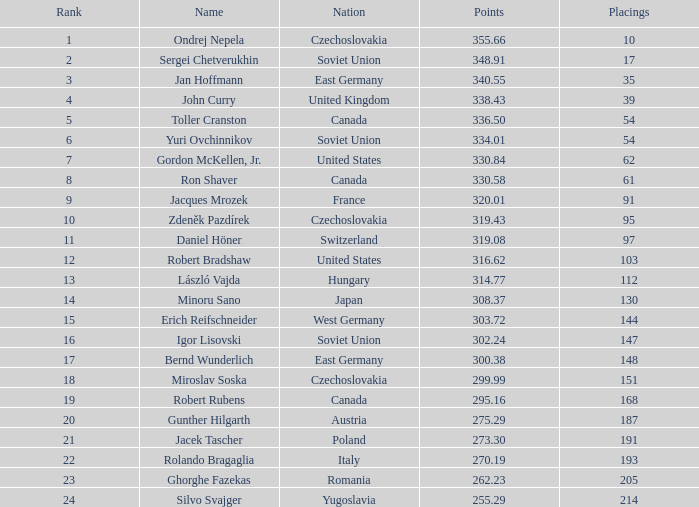Which Placings have a Nation of west germany, and Points larger than 303.72? None. 